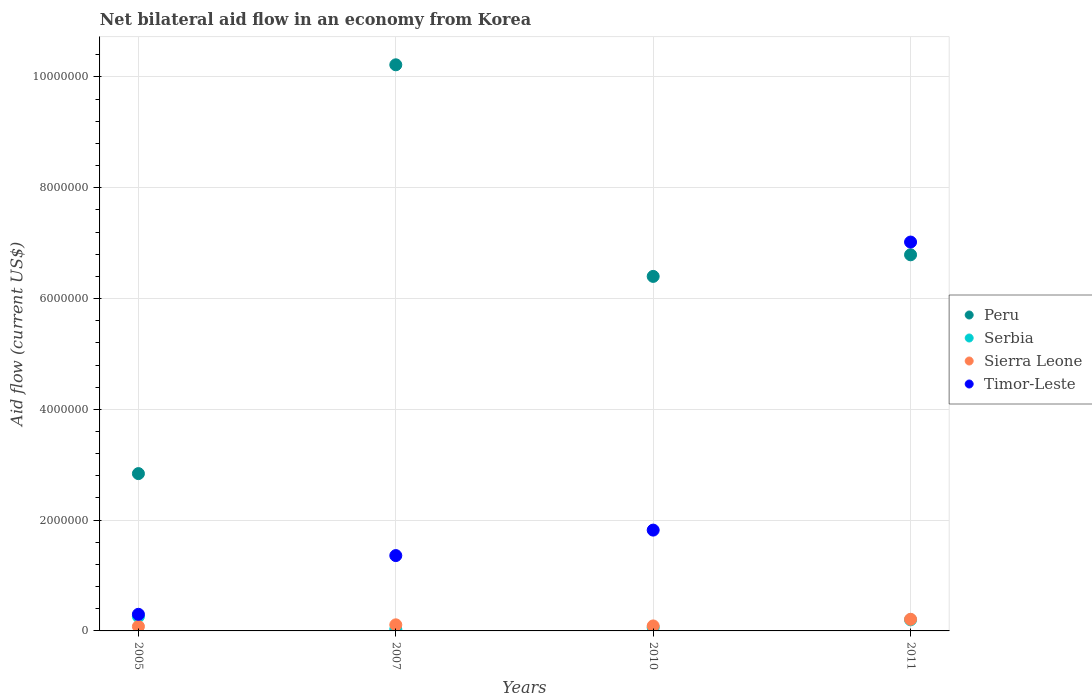Is the number of dotlines equal to the number of legend labels?
Ensure brevity in your answer.  Yes. What is the net bilateral aid flow in Timor-Leste in 2010?
Offer a terse response. 1.82e+06. Across all years, what is the maximum net bilateral aid flow in Serbia?
Give a very brief answer. 2.60e+05. Across all years, what is the minimum net bilateral aid flow in Peru?
Your answer should be very brief. 2.84e+06. In which year was the net bilateral aid flow in Peru maximum?
Your response must be concise. 2007. What is the total net bilateral aid flow in Serbia in the graph?
Offer a very short reply. 5.50e+05. What is the difference between the net bilateral aid flow in Sierra Leone in 2007 and the net bilateral aid flow in Timor-Leste in 2010?
Provide a short and direct response. -1.71e+06. What is the average net bilateral aid flow in Timor-Leste per year?
Provide a succinct answer. 2.62e+06. In the year 2007, what is the difference between the net bilateral aid flow in Serbia and net bilateral aid flow in Sierra Leone?
Offer a terse response. -8.00e+04. In how many years, is the net bilateral aid flow in Serbia greater than 800000 US$?
Make the answer very short. 0. What is the ratio of the net bilateral aid flow in Sierra Leone in 2010 to that in 2011?
Your response must be concise. 0.43. Is the difference between the net bilateral aid flow in Serbia in 2007 and 2011 greater than the difference between the net bilateral aid flow in Sierra Leone in 2007 and 2011?
Your answer should be very brief. No. What is the difference between the highest and the second highest net bilateral aid flow in Peru?
Provide a succinct answer. 3.43e+06. What is the difference between the highest and the lowest net bilateral aid flow in Timor-Leste?
Provide a short and direct response. 6.72e+06. Is the sum of the net bilateral aid flow in Peru in 2005 and 2011 greater than the maximum net bilateral aid flow in Sierra Leone across all years?
Offer a terse response. Yes. Does the net bilateral aid flow in Sierra Leone monotonically increase over the years?
Your answer should be very brief. No. Is the net bilateral aid flow in Peru strictly less than the net bilateral aid flow in Timor-Leste over the years?
Offer a terse response. No. What is the difference between two consecutive major ticks on the Y-axis?
Ensure brevity in your answer.  2.00e+06. Does the graph contain any zero values?
Your answer should be compact. No. What is the title of the graph?
Your answer should be very brief. Net bilateral aid flow in an economy from Korea. Does "East Asia (all income levels)" appear as one of the legend labels in the graph?
Your response must be concise. No. What is the Aid flow (current US$) in Peru in 2005?
Your response must be concise. 2.84e+06. What is the Aid flow (current US$) in Timor-Leste in 2005?
Your response must be concise. 3.00e+05. What is the Aid flow (current US$) in Peru in 2007?
Provide a succinct answer. 1.02e+07. What is the Aid flow (current US$) of Sierra Leone in 2007?
Give a very brief answer. 1.10e+05. What is the Aid flow (current US$) in Timor-Leste in 2007?
Make the answer very short. 1.36e+06. What is the Aid flow (current US$) of Peru in 2010?
Make the answer very short. 6.40e+06. What is the Aid flow (current US$) in Timor-Leste in 2010?
Offer a very short reply. 1.82e+06. What is the Aid flow (current US$) of Peru in 2011?
Your answer should be very brief. 6.79e+06. What is the Aid flow (current US$) in Timor-Leste in 2011?
Offer a terse response. 7.02e+06. Across all years, what is the maximum Aid flow (current US$) of Peru?
Make the answer very short. 1.02e+07. Across all years, what is the maximum Aid flow (current US$) in Timor-Leste?
Your answer should be compact. 7.02e+06. Across all years, what is the minimum Aid flow (current US$) in Peru?
Your answer should be compact. 2.84e+06. Across all years, what is the minimum Aid flow (current US$) in Serbia?
Keep it short and to the point. 3.00e+04. Across all years, what is the minimum Aid flow (current US$) of Sierra Leone?
Your answer should be compact. 8.00e+04. What is the total Aid flow (current US$) of Peru in the graph?
Provide a short and direct response. 2.62e+07. What is the total Aid flow (current US$) in Timor-Leste in the graph?
Ensure brevity in your answer.  1.05e+07. What is the difference between the Aid flow (current US$) of Peru in 2005 and that in 2007?
Your answer should be compact. -7.38e+06. What is the difference between the Aid flow (current US$) of Serbia in 2005 and that in 2007?
Your response must be concise. 2.30e+05. What is the difference between the Aid flow (current US$) of Sierra Leone in 2005 and that in 2007?
Provide a succinct answer. -3.00e+04. What is the difference between the Aid flow (current US$) of Timor-Leste in 2005 and that in 2007?
Keep it short and to the point. -1.06e+06. What is the difference between the Aid flow (current US$) in Peru in 2005 and that in 2010?
Keep it short and to the point. -3.56e+06. What is the difference between the Aid flow (current US$) of Sierra Leone in 2005 and that in 2010?
Provide a succinct answer. -10000. What is the difference between the Aid flow (current US$) of Timor-Leste in 2005 and that in 2010?
Offer a terse response. -1.52e+06. What is the difference between the Aid flow (current US$) in Peru in 2005 and that in 2011?
Your answer should be very brief. -3.95e+06. What is the difference between the Aid flow (current US$) in Serbia in 2005 and that in 2011?
Ensure brevity in your answer.  6.00e+04. What is the difference between the Aid flow (current US$) of Timor-Leste in 2005 and that in 2011?
Offer a terse response. -6.72e+06. What is the difference between the Aid flow (current US$) in Peru in 2007 and that in 2010?
Give a very brief answer. 3.82e+06. What is the difference between the Aid flow (current US$) in Timor-Leste in 2007 and that in 2010?
Ensure brevity in your answer.  -4.60e+05. What is the difference between the Aid flow (current US$) in Peru in 2007 and that in 2011?
Give a very brief answer. 3.43e+06. What is the difference between the Aid flow (current US$) of Serbia in 2007 and that in 2011?
Provide a succinct answer. -1.70e+05. What is the difference between the Aid flow (current US$) in Timor-Leste in 2007 and that in 2011?
Your answer should be compact. -5.66e+06. What is the difference between the Aid flow (current US$) of Peru in 2010 and that in 2011?
Ensure brevity in your answer.  -3.90e+05. What is the difference between the Aid flow (current US$) in Sierra Leone in 2010 and that in 2011?
Make the answer very short. -1.20e+05. What is the difference between the Aid flow (current US$) in Timor-Leste in 2010 and that in 2011?
Your answer should be very brief. -5.20e+06. What is the difference between the Aid flow (current US$) in Peru in 2005 and the Aid flow (current US$) in Serbia in 2007?
Provide a short and direct response. 2.81e+06. What is the difference between the Aid flow (current US$) of Peru in 2005 and the Aid flow (current US$) of Sierra Leone in 2007?
Provide a succinct answer. 2.73e+06. What is the difference between the Aid flow (current US$) of Peru in 2005 and the Aid flow (current US$) of Timor-Leste in 2007?
Offer a very short reply. 1.48e+06. What is the difference between the Aid flow (current US$) in Serbia in 2005 and the Aid flow (current US$) in Sierra Leone in 2007?
Ensure brevity in your answer.  1.50e+05. What is the difference between the Aid flow (current US$) in Serbia in 2005 and the Aid flow (current US$) in Timor-Leste in 2007?
Your answer should be very brief. -1.10e+06. What is the difference between the Aid flow (current US$) of Sierra Leone in 2005 and the Aid flow (current US$) of Timor-Leste in 2007?
Make the answer very short. -1.28e+06. What is the difference between the Aid flow (current US$) in Peru in 2005 and the Aid flow (current US$) in Serbia in 2010?
Give a very brief answer. 2.78e+06. What is the difference between the Aid flow (current US$) in Peru in 2005 and the Aid flow (current US$) in Sierra Leone in 2010?
Your response must be concise. 2.75e+06. What is the difference between the Aid flow (current US$) in Peru in 2005 and the Aid flow (current US$) in Timor-Leste in 2010?
Your answer should be very brief. 1.02e+06. What is the difference between the Aid flow (current US$) in Serbia in 2005 and the Aid flow (current US$) in Timor-Leste in 2010?
Ensure brevity in your answer.  -1.56e+06. What is the difference between the Aid flow (current US$) in Sierra Leone in 2005 and the Aid flow (current US$) in Timor-Leste in 2010?
Your answer should be compact. -1.74e+06. What is the difference between the Aid flow (current US$) in Peru in 2005 and the Aid flow (current US$) in Serbia in 2011?
Make the answer very short. 2.64e+06. What is the difference between the Aid flow (current US$) of Peru in 2005 and the Aid flow (current US$) of Sierra Leone in 2011?
Keep it short and to the point. 2.63e+06. What is the difference between the Aid flow (current US$) of Peru in 2005 and the Aid flow (current US$) of Timor-Leste in 2011?
Provide a succinct answer. -4.18e+06. What is the difference between the Aid flow (current US$) in Serbia in 2005 and the Aid flow (current US$) in Sierra Leone in 2011?
Keep it short and to the point. 5.00e+04. What is the difference between the Aid flow (current US$) in Serbia in 2005 and the Aid flow (current US$) in Timor-Leste in 2011?
Keep it short and to the point. -6.76e+06. What is the difference between the Aid flow (current US$) in Sierra Leone in 2005 and the Aid flow (current US$) in Timor-Leste in 2011?
Provide a succinct answer. -6.94e+06. What is the difference between the Aid flow (current US$) of Peru in 2007 and the Aid flow (current US$) of Serbia in 2010?
Offer a very short reply. 1.02e+07. What is the difference between the Aid flow (current US$) of Peru in 2007 and the Aid flow (current US$) of Sierra Leone in 2010?
Offer a terse response. 1.01e+07. What is the difference between the Aid flow (current US$) in Peru in 2007 and the Aid flow (current US$) in Timor-Leste in 2010?
Provide a succinct answer. 8.40e+06. What is the difference between the Aid flow (current US$) in Serbia in 2007 and the Aid flow (current US$) in Timor-Leste in 2010?
Give a very brief answer. -1.79e+06. What is the difference between the Aid flow (current US$) in Sierra Leone in 2007 and the Aid flow (current US$) in Timor-Leste in 2010?
Offer a terse response. -1.71e+06. What is the difference between the Aid flow (current US$) in Peru in 2007 and the Aid flow (current US$) in Serbia in 2011?
Keep it short and to the point. 1.00e+07. What is the difference between the Aid flow (current US$) in Peru in 2007 and the Aid flow (current US$) in Sierra Leone in 2011?
Your answer should be compact. 1.00e+07. What is the difference between the Aid flow (current US$) of Peru in 2007 and the Aid flow (current US$) of Timor-Leste in 2011?
Give a very brief answer. 3.20e+06. What is the difference between the Aid flow (current US$) of Serbia in 2007 and the Aid flow (current US$) of Sierra Leone in 2011?
Your response must be concise. -1.80e+05. What is the difference between the Aid flow (current US$) of Serbia in 2007 and the Aid flow (current US$) of Timor-Leste in 2011?
Make the answer very short. -6.99e+06. What is the difference between the Aid flow (current US$) of Sierra Leone in 2007 and the Aid flow (current US$) of Timor-Leste in 2011?
Ensure brevity in your answer.  -6.91e+06. What is the difference between the Aid flow (current US$) in Peru in 2010 and the Aid flow (current US$) in Serbia in 2011?
Offer a terse response. 6.20e+06. What is the difference between the Aid flow (current US$) in Peru in 2010 and the Aid flow (current US$) in Sierra Leone in 2011?
Offer a terse response. 6.19e+06. What is the difference between the Aid flow (current US$) of Peru in 2010 and the Aid flow (current US$) of Timor-Leste in 2011?
Ensure brevity in your answer.  -6.20e+05. What is the difference between the Aid flow (current US$) of Serbia in 2010 and the Aid flow (current US$) of Timor-Leste in 2011?
Offer a very short reply. -6.96e+06. What is the difference between the Aid flow (current US$) of Sierra Leone in 2010 and the Aid flow (current US$) of Timor-Leste in 2011?
Make the answer very short. -6.93e+06. What is the average Aid flow (current US$) in Peru per year?
Keep it short and to the point. 6.56e+06. What is the average Aid flow (current US$) in Serbia per year?
Your answer should be compact. 1.38e+05. What is the average Aid flow (current US$) of Sierra Leone per year?
Your answer should be compact. 1.22e+05. What is the average Aid flow (current US$) in Timor-Leste per year?
Offer a very short reply. 2.62e+06. In the year 2005, what is the difference between the Aid flow (current US$) in Peru and Aid flow (current US$) in Serbia?
Your answer should be compact. 2.58e+06. In the year 2005, what is the difference between the Aid flow (current US$) in Peru and Aid flow (current US$) in Sierra Leone?
Your answer should be compact. 2.76e+06. In the year 2005, what is the difference between the Aid flow (current US$) of Peru and Aid flow (current US$) of Timor-Leste?
Offer a terse response. 2.54e+06. In the year 2007, what is the difference between the Aid flow (current US$) in Peru and Aid flow (current US$) in Serbia?
Offer a terse response. 1.02e+07. In the year 2007, what is the difference between the Aid flow (current US$) in Peru and Aid flow (current US$) in Sierra Leone?
Give a very brief answer. 1.01e+07. In the year 2007, what is the difference between the Aid flow (current US$) of Peru and Aid flow (current US$) of Timor-Leste?
Provide a succinct answer. 8.86e+06. In the year 2007, what is the difference between the Aid flow (current US$) in Serbia and Aid flow (current US$) in Timor-Leste?
Keep it short and to the point. -1.33e+06. In the year 2007, what is the difference between the Aid flow (current US$) of Sierra Leone and Aid flow (current US$) of Timor-Leste?
Offer a terse response. -1.25e+06. In the year 2010, what is the difference between the Aid flow (current US$) of Peru and Aid flow (current US$) of Serbia?
Ensure brevity in your answer.  6.34e+06. In the year 2010, what is the difference between the Aid flow (current US$) in Peru and Aid flow (current US$) in Sierra Leone?
Give a very brief answer. 6.31e+06. In the year 2010, what is the difference between the Aid flow (current US$) in Peru and Aid flow (current US$) in Timor-Leste?
Make the answer very short. 4.58e+06. In the year 2010, what is the difference between the Aid flow (current US$) in Serbia and Aid flow (current US$) in Timor-Leste?
Offer a very short reply. -1.76e+06. In the year 2010, what is the difference between the Aid flow (current US$) in Sierra Leone and Aid flow (current US$) in Timor-Leste?
Your answer should be compact. -1.73e+06. In the year 2011, what is the difference between the Aid flow (current US$) of Peru and Aid flow (current US$) of Serbia?
Ensure brevity in your answer.  6.59e+06. In the year 2011, what is the difference between the Aid flow (current US$) in Peru and Aid flow (current US$) in Sierra Leone?
Your response must be concise. 6.58e+06. In the year 2011, what is the difference between the Aid flow (current US$) in Peru and Aid flow (current US$) in Timor-Leste?
Your answer should be very brief. -2.30e+05. In the year 2011, what is the difference between the Aid flow (current US$) of Serbia and Aid flow (current US$) of Sierra Leone?
Offer a very short reply. -10000. In the year 2011, what is the difference between the Aid flow (current US$) of Serbia and Aid flow (current US$) of Timor-Leste?
Make the answer very short. -6.82e+06. In the year 2011, what is the difference between the Aid flow (current US$) in Sierra Leone and Aid flow (current US$) in Timor-Leste?
Make the answer very short. -6.81e+06. What is the ratio of the Aid flow (current US$) of Peru in 2005 to that in 2007?
Offer a terse response. 0.28. What is the ratio of the Aid flow (current US$) in Serbia in 2005 to that in 2007?
Offer a very short reply. 8.67. What is the ratio of the Aid flow (current US$) of Sierra Leone in 2005 to that in 2007?
Keep it short and to the point. 0.73. What is the ratio of the Aid flow (current US$) of Timor-Leste in 2005 to that in 2007?
Give a very brief answer. 0.22. What is the ratio of the Aid flow (current US$) of Peru in 2005 to that in 2010?
Offer a terse response. 0.44. What is the ratio of the Aid flow (current US$) in Serbia in 2005 to that in 2010?
Provide a short and direct response. 4.33. What is the ratio of the Aid flow (current US$) in Timor-Leste in 2005 to that in 2010?
Provide a short and direct response. 0.16. What is the ratio of the Aid flow (current US$) in Peru in 2005 to that in 2011?
Ensure brevity in your answer.  0.42. What is the ratio of the Aid flow (current US$) of Sierra Leone in 2005 to that in 2011?
Offer a very short reply. 0.38. What is the ratio of the Aid flow (current US$) of Timor-Leste in 2005 to that in 2011?
Keep it short and to the point. 0.04. What is the ratio of the Aid flow (current US$) in Peru in 2007 to that in 2010?
Make the answer very short. 1.6. What is the ratio of the Aid flow (current US$) in Sierra Leone in 2007 to that in 2010?
Your answer should be compact. 1.22. What is the ratio of the Aid flow (current US$) in Timor-Leste in 2007 to that in 2010?
Offer a very short reply. 0.75. What is the ratio of the Aid flow (current US$) of Peru in 2007 to that in 2011?
Your answer should be compact. 1.51. What is the ratio of the Aid flow (current US$) in Sierra Leone in 2007 to that in 2011?
Provide a short and direct response. 0.52. What is the ratio of the Aid flow (current US$) in Timor-Leste in 2007 to that in 2011?
Your response must be concise. 0.19. What is the ratio of the Aid flow (current US$) of Peru in 2010 to that in 2011?
Make the answer very short. 0.94. What is the ratio of the Aid flow (current US$) of Sierra Leone in 2010 to that in 2011?
Ensure brevity in your answer.  0.43. What is the ratio of the Aid flow (current US$) in Timor-Leste in 2010 to that in 2011?
Keep it short and to the point. 0.26. What is the difference between the highest and the second highest Aid flow (current US$) in Peru?
Your answer should be very brief. 3.43e+06. What is the difference between the highest and the second highest Aid flow (current US$) of Sierra Leone?
Give a very brief answer. 1.00e+05. What is the difference between the highest and the second highest Aid flow (current US$) in Timor-Leste?
Make the answer very short. 5.20e+06. What is the difference between the highest and the lowest Aid flow (current US$) in Peru?
Give a very brief answer. 7.38e+06. What is the difference between the highest and the lowest Aid flow (current US$) in Sierra Leone?
Offer a terse response. 1.30e+05. What is the difference between the highest and the lowest Aid flow (current US$) of Timor-Leste?
Your answer should be very brief. 6.72e+06. 